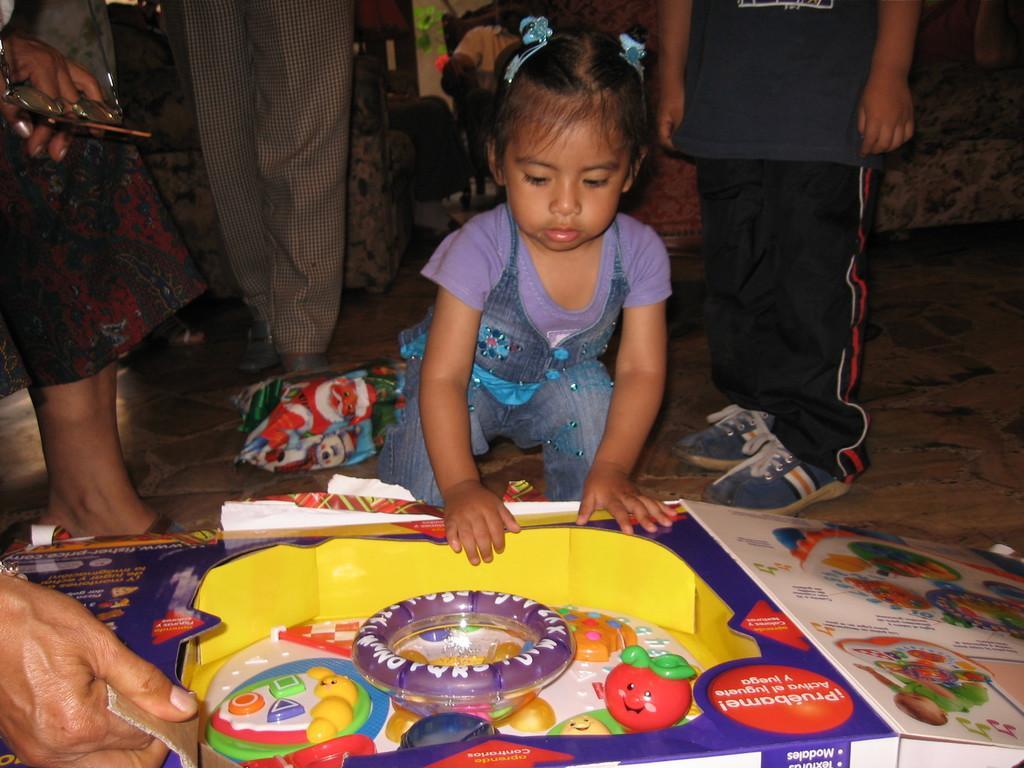Could you give a brief overview of what you see in this image? In this picture we can see few people, in the middle of the image we can see a girl, in front of her we can see a box and few toys, in the background we can see a sofa. 